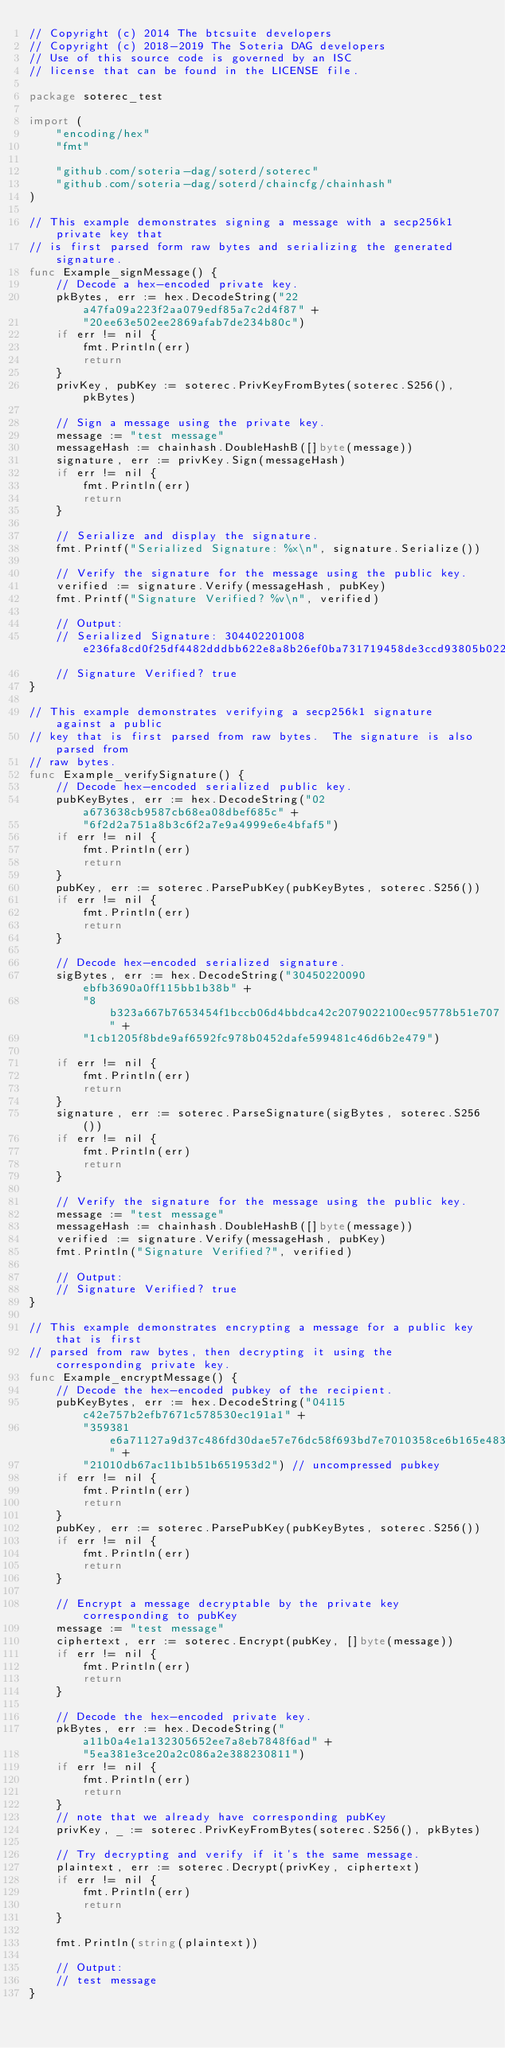<code> <loc_0><loc_0><loc_500><loc_500><_Go_>// Copyright (c) 2014 The btcsuite developers
// Copyright (c) 2018-2019 The Soteria DAG developers
// Use of this source code is governed by an ISC
// license that can be found in the LICENSE file.

package soterec_test

import (
	"encoding/hex"
	"fmt"

	"github.com/soteria-dag/soterd/soterec"
	"github.com/soteria-dag/soterd/chaincfg/chainhash"
)

// This example demonstrates signing a message with a secp256k1 private key that
// is first parsed form raw bytes and serializing the generated signature.
func Example_signMessage() {
	// Decode a hex-encoded private key.
	pkBytes, err := hex.DecodeString("22a47fa09a223f2aa079edf85a7c2d4f87" +
		"20ee63e502ee2869afab7de234b80c")
	if err != nil {
		fmt.Println(err)
		return
	}
	privKey, pubKey := soterec.PrivKeyFromBytes(soterec.S256(), pkBytes)

	// Sign a message using the private key.
	message := "test message"
	messageHash := chainhash.DoubleHashB([]byte(message))
	signature, err := privKey.Sign(messageHash)
	if err != nil {
		fmt.Println(err)
		return
	}

	// Serialize and display the signature.
	fmt.Printf("Serialized Signature: %x\n", signature.Serialize())

	// Verify the signature for the message using the public key.
	verified := signature.Verify(messageHash, pubKey)
	fmt.Printf("Signature Verified? %v\n", verified)

	// Output:
	// Serialized Signature: 304402201008e236fa8cd0f25df4482dddbb622e8a8b26ef0ba731719458de3ccd93805b022032f8ebe514ba5f672466eba334639282616bb3c2f0ab09998037513d1f9e3d6d
	// Signature Verified? true
}

// This example demonstrates verifying a secp256k1 signature against a public
// key that is first parsed from raw bytes.  The signature is also parsed from
// raw bytes.
func Example_verifySignature() {
	// Decode hex-encoded serialized public key.
	pubKeyBytes, err := hex.DecodeString("02a673638cb9587cb68ea08dbef685c" +
		"6f2d2a751a8b3c6f2a7e9a4999e6e4bfaf5")
	if err != nil {
		fmt.Println(err)
		return
	}
	pubKey, err := soterec.ParsePubKey(pubKeyBytes, soterec.S256())
	if err != nil {
		fmt.Println(err)
		return
	}

	// Decode hex-encoded serialized signature.
	sigBytes, err := hex.DecodeString("30450220090ebfb3690a0ff115bb1b38b" +
		"8b323a667b7653454f1bccb06d4bbdca42c2079022100ec95778b51e707" +
		"1cb1205f8bde9af6592fc978b0452dafe599481c46d6b2e479")

	if err != nil {
		fmt.Println(err)
		return
	}
	signature, err := soterec.ParseSignature(sigBytes, soterec.S256())
	if err != nil {
		fmt.Println(err)
		return
	}

	// Verify the signature for the message using the public key.
	message := "test message"
	messageHash := chainhash.DoubleHashB([]byte(message))
	verified := signature.Verify(messageHash, pubKey)
	fmt.Println("Signature Verified?", verified)

	// Output:
	// Signature Verified? true
}

// This example demonstrates encrypting a message for a public key that is first
// parsed from raw bytes, then decrypting it using the corresponding private key.
func Example_encryptMessage() {
	// Decode the hex-encoded pubkey of the recipient.
	pubKeyBytes, err := hex.DecodeString("04115c42e757b2efb7671c578530ec191a1" +
		"359381e6a71127a9d37c486fd30dae57e76dc58f693bd7e7010358ce6b165e483a29" +
		"21010db67ac11b1b51b651953d2") // uncompressed pubkey
	if err != nil {
		fmt.Println(err)
		return
	}
	pubKey, err := soterec.ParsePubKey(pubKeyBytes, soterec.S256())
	if err != nil {
		fmt.Println(err)
		return
	}

	// Encrypt a message decryptable by the private key corresponding to pubKey
	message := "test message"
	ciphertext, err := soterec.Encrypt(pubKey, []byte(message))
	if err != nil {
		fmt.Println(err)
		return
	}

	// Decode the hex-encoded private key.
	pkBytes, err := hex.DecodeString("a11b0a4e1a132305652ee7a8eb7848f6ad" +
		"5ea381e3ce20a2c086a2e388230811")
	if err != nil {
		fmt.Println(err)
		return
	}
	// note that we already have corresponding pubKey
	privKey, _ := soterec.PrivKeyFromBytes(soterec.S256(), pkBytes)

	// Try decrypting and verify if it's the same message.
	plaintext, err := soterec.Decrypt(privKey, ciphertext)
	if err != nil {
		fmt.Println(err)
		return
	}

	fmt.Println(string(plaintext))

	// Output:
	// test message
}
</code> 